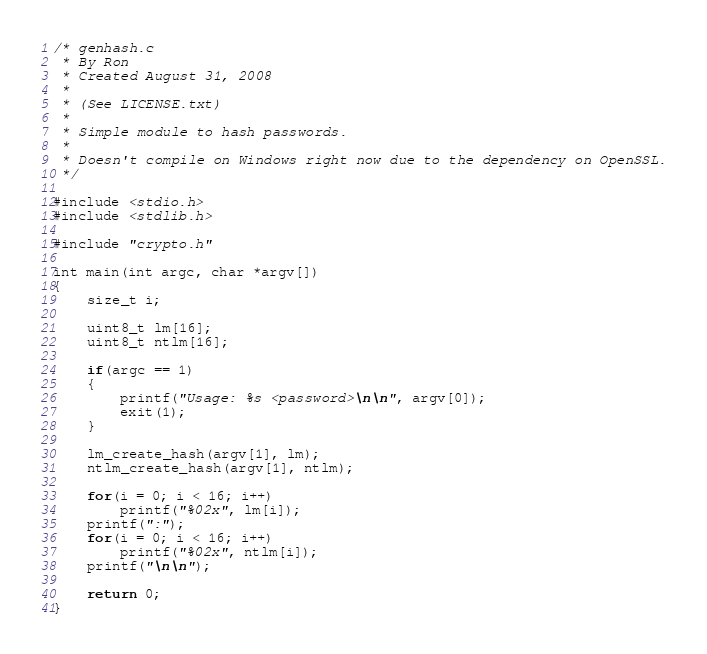Convert code to text. <code><loc_0><loc_0><loc_500><loc_500><_C_>/* genhash.c
 * By Ron
 * Created August 31, 2008
 *
 * (See LICENSE.txt)
 *
 * Simple module to hash passwords.
 *
 * Doesn't compile on Windows right now due to the dependency on OpenSSL.
 */

#include <stdio.h>
#include <stdlib.h>

#include "crypto.h"

int main(int argc, char *argv[])
{
	size_t i;

	uint8_t lm[16];
	uint8_t ntlm[16];

	if(argc == 1)
	{
		printf("Usage: %s <password>\n\n", argv[0]);
		exit(1);
	}

	lm_create_hash(argv[1], lm);
	ntlm_create_hash(argv[1], ntlm);

	for(i = 0; i < 16; i++)
		printf("%02x", lm[i]);
	printf(":");
	for(i = 0; i < 16; i++)
		printf("%02x", ntlm[i]);
	printf("\n\n");

	return 0;
}

</code> 